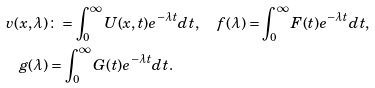<formula> <loc_0><loc_0><loc_500><loc_500>v ( x , \lambda ) & \colon = \int _ { 0 } ^ { \infty } U ( x , t ) e ^ { - \lambda t } d t , \quad f ( \lambda ) = \int _ { 0 } ^ { \infty } F ( t ) e ^ { - \lambda t } d t , \\ g ( \lambda ) & = \int _ { 0 } ^ { \infty } G ( t ) e ^ { - \lambda t } d t .</formula> 